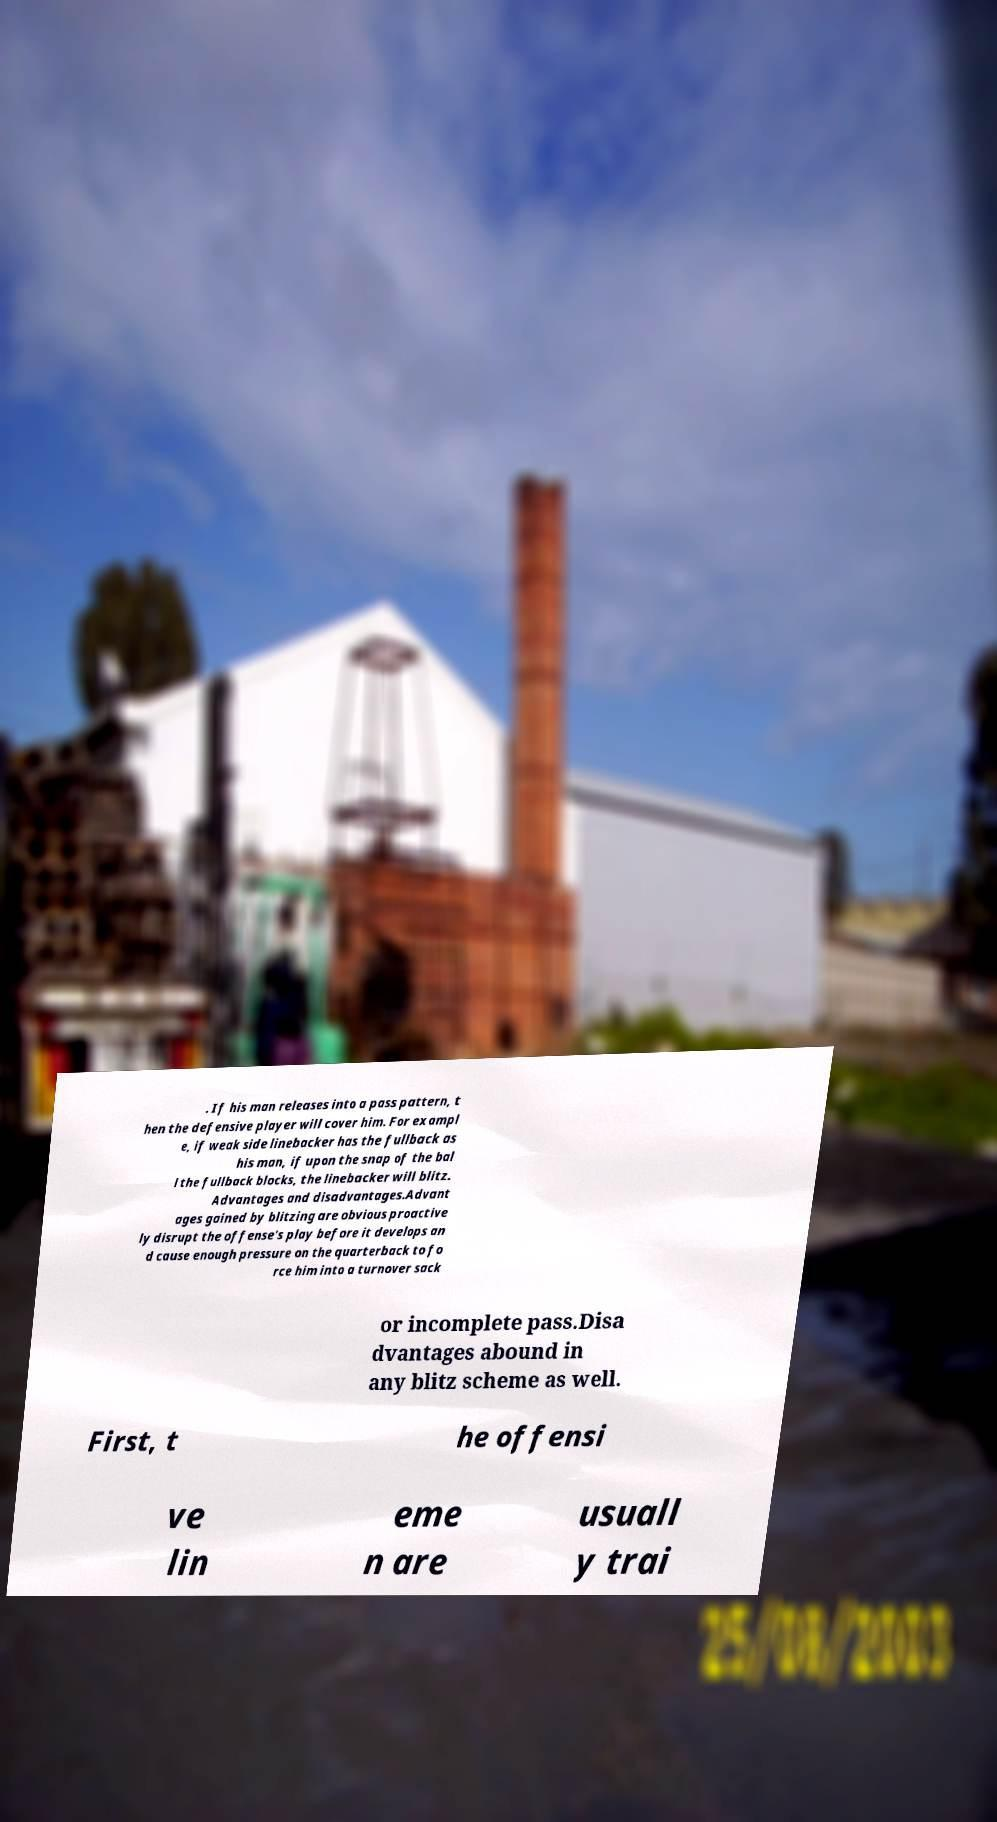Please identify and transcribe the text found in this image. . If his man releases into a pass pattern, t hen the defensive player will cover him. For exampl e, if weak side linebacker has the fullback as his man, if upon the snap of the bal l the fullback blocks, the linebacker will blitz. Advantages and disadvantages.Advant ages gained by blitzing are obvious proactive ly disrupt the offense's play before it develops an d cause enough pressure on the quarterback to fo rce him into a turnover sack or incomplete pass.Disa dvantages abound in any blitz scheme as well. First, t he offensi ve lin eme n are usuall y trai 